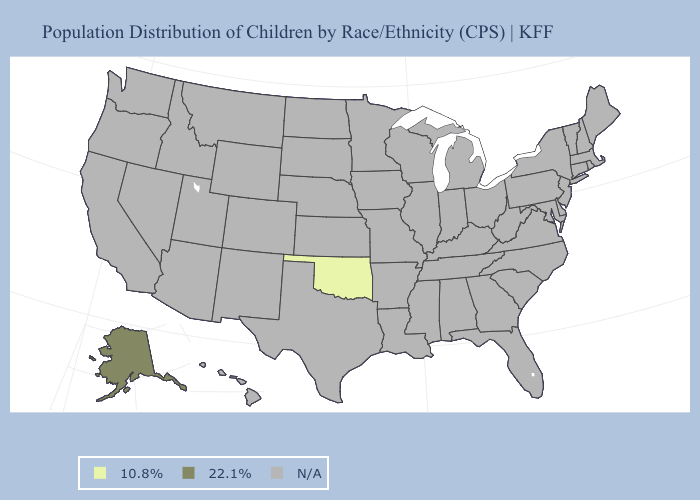Which states have the lowest value in the USA?
Quick response, please. Oklahoma. How many symbols are there in the legend?
Quick response, please. 3. Name the states that have a value in the range 10.8%?
Answer briefly. Oklahoma. Name the states that have a value in the range 22.1%?
Quick response, please. Alaska. Name the states that have a value in the range N/A?
Write a very short answer. Alabama, Arizona, Arkansas, California, Colorado, Connecticut, Delaware, Florida, Georgia, Hawaii, Idaho, Illinois, Indiana, Iowa, Kansas, Kentucky, Louisiana, Maine, Maryland, Massachusetts, Michigan, Minnesota, Mississippi, Missouri, Montana, Nebraska, Nevada, New Hampshire, New Jersey, New Mexico, New York, North Carolina, North Dakota, Ohio, Oregon, Pennsylvania, Rhode Island, South Carolina, South Dakota, Tennessee, Texas, Utah, Vermont, Virginia, Washington, West Virginia, Wisconsin, Wyoming. Is the legend a continuous bar?
Keep it brief. No. What is the value of Alaska?
Answer briefly. 22.1%. What is the value of Mississippi?
Answer briefly. N/A. How many symbols are there in the legend?
Give a very brief answer. 3. 